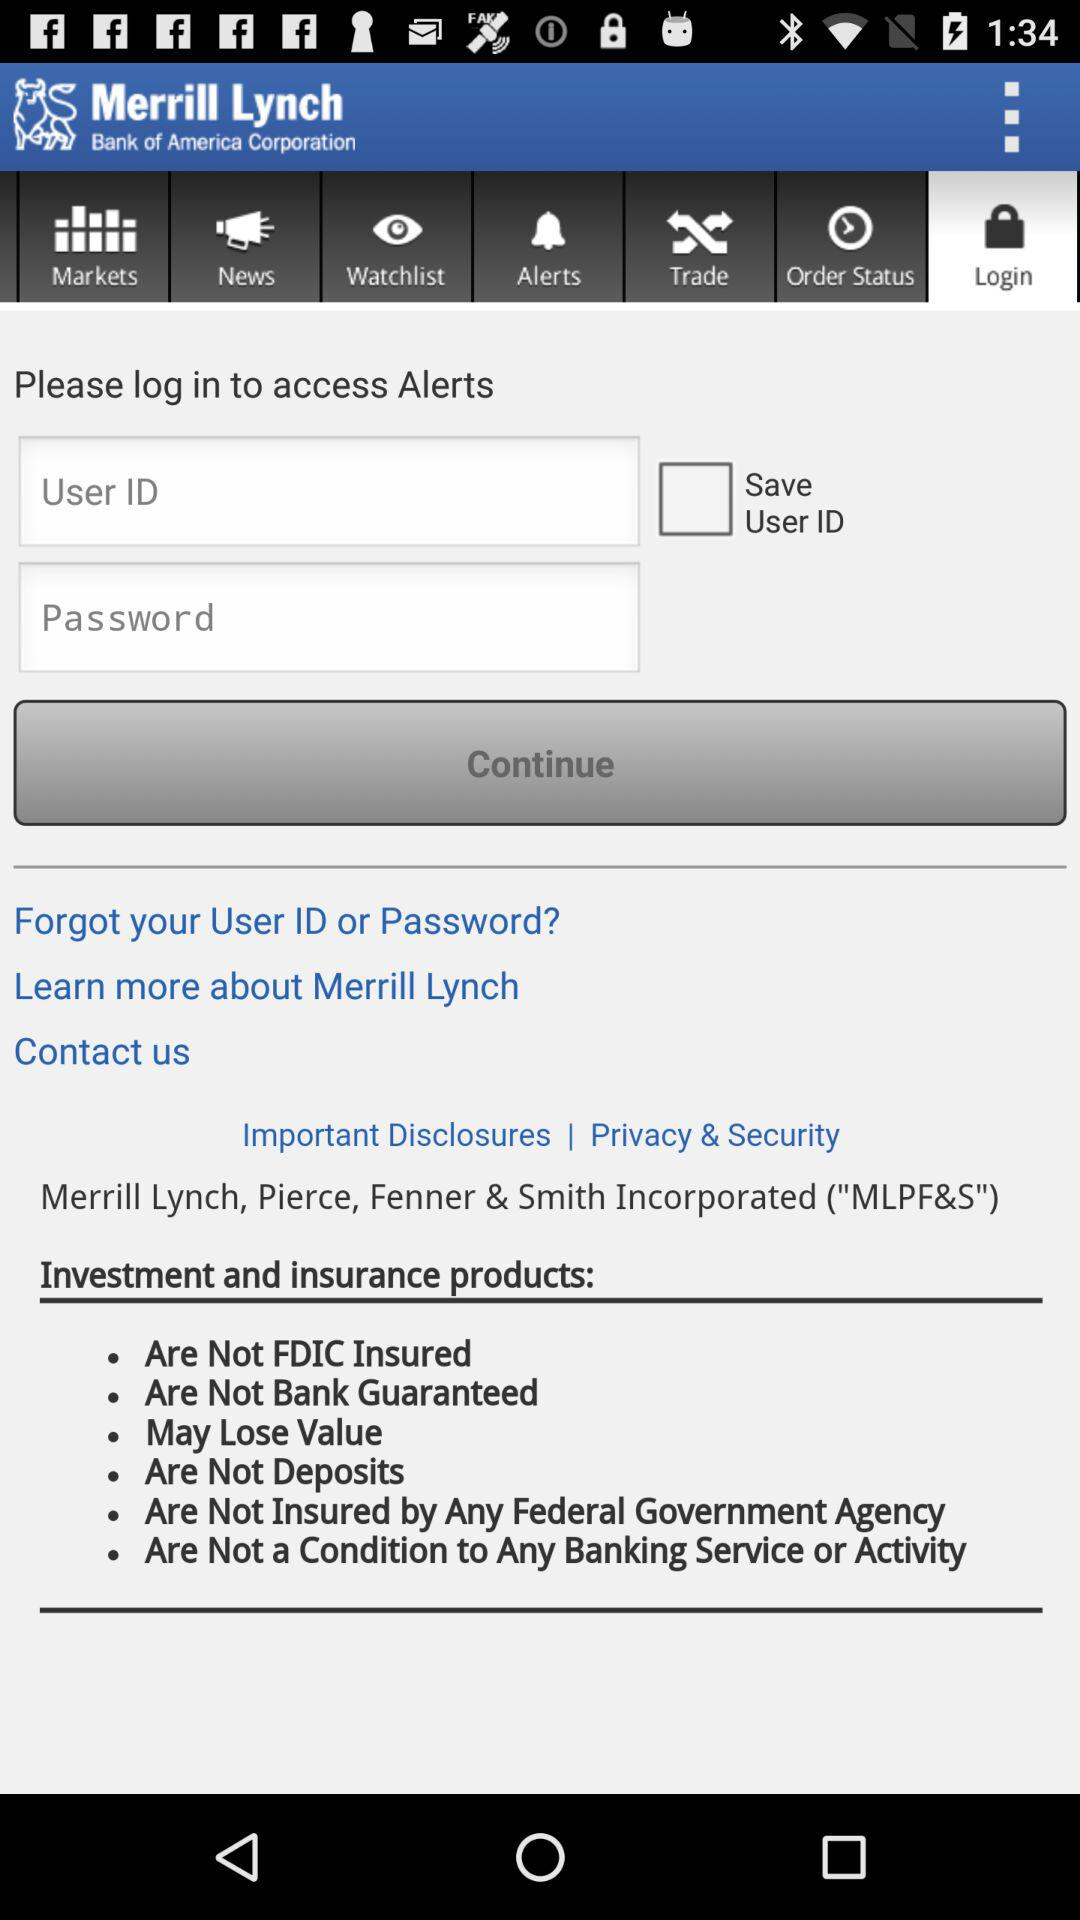What is the status of "Save User ID"? The status is off. 